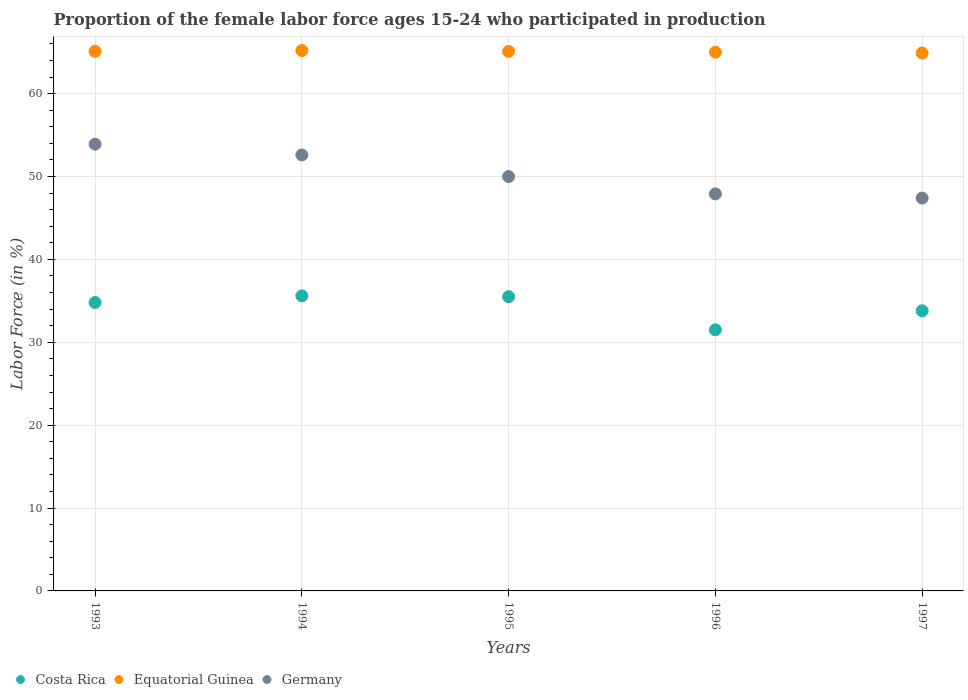How many different coloured dotlines are there?
Provide a succinct answer. 3. Is the number of dotlines equal to the number of legend labels?
Provide a succinct answer. Yes. What is the proportion of the female labor force who participated in production in Costa Rica in 1997?
Your answer should be compact. 33.8. Across all years, what is the maximum proportion of the female labor force who participated in production in Costa Rica?
Your answer should be very brief. 35.6. Across all years, what is the minimum proportion of the female labor force who participated in production in Equatorial Guinea?
Your answer should be very brief. 64.9. In which year was the proportion of the female labor force who participated in production in Equatorial Guinea maximum?
Ensure brevity in your answer.  1994. In which year was the proportion of the female labor force who participated in production in Germany minimum?
Make the answer very short. 1997. What is the total proportion of the female labor force who participated in production in Costa Rica in the graph?
Ensure brevity in your answer.  171.2. What is the difference between the proportion of the female labor force who participated in production in Equatorial Guinea in 1995 and that in 1996?
Your response must be concise. 0.1. What is the difference between the proportion of the female labor force who participated in production in Germany in 1995 and the proportion of the female labor force who participated in production in Equatorial Guinea in 1996?
Make the answer very short. -15. What is the average proportion of the female labor force who participated in production in Germany per year?
Ensure brevity in your answer.  50.36. In the year 1996, what is the difference between the proportion of the female labor force who participated in production in Equatorial Guinea and proportion of the female labor force who participated in production in Germany?
Make the answer very short. 17.1. What is the ratio of the proportion of the female labor force who participated in production in Equatorial Guinea in 1994 to that in 1997?
Ensure brevity in your answer.  1. Is the difference between the proportion of the female labor force who participated in production in Equatorial Guinea in 1993 and 1997 greater than the difference between the proportion of the female labor force who participated in production in Germany in 1993 and 1997?
Provide a short and direct response. No. What is the difference between the highest and the second highest proportion of the female labor force who participated in production in Equatorial Guinea?
Your answer should be very brief. 0.1. What is the difference between the highest and the lowest proportion of the female labor force who participated in production in Equatorial Guinea?
Provide a short and direct response. 0.3. In how many years, is the proportion of the female labor force who participated in production in Costa Rica greater than the average proportion of the female labor force who participated in production in Costa Rica taken over all years?
Your answer should be compact. 3. Does the proportion of the female labor force who participated in production in Equatorial Guinea monotonically increase over the years?
Keep it short and to the point. No. Are the values on the major ticks of Y-axis written in scientific E-notation?
Give a very brief answer. No. Does the graph contain any zero values?
Provide a short and direct response. No. How many legend labels are there?
Offer a very short reply. 3. What is the title of the graph?
Offer a very short reply. Proportion of the female labor force ages 15-24 who participated in production. Does "Morocco" appear as one of the legend labels in the graph?
Ensure brevity in your answer.  No. What is the label or title of the X-axis?
Offer a very short reply. Years. What is the label or title of the Y-axis?
Keep it short and to the point. Labor Force (in %). What is the Labor Force (in %) in Costa Rica in 1993?
Provide a succinct answer. 34.8. What is the Labor Force (in %) of Equatorial Guinea in 1993?
Ensure brevity in your answer.  65.1. What is the Labor Force (in %) in Germany in 1993?
Keep it short and to the point. 53.9. What is the Labor Force (in %) of Costa Rica in 1994?
Give a very brief answer. 35.6. What is the Labor Force (in %) in Equatorial Guinea in 1994?
Ensure brevity in your answer.  65.2. What is the Labor Force (in %) of Germany in 1994?
Make the answer very short. 52.6. What is the Labor Force (in %) in Costa Rica in 1995?
Your answer should be very brief. 35.5. What is the Labor Force (in %) in Equatorial Guinea in 1995?
Your answer should be compact. 65.1. What is the Labor Force (in %) of Germany in 1995?
Make the answer very short. 50. What is the Labor Force (in %) in Costa Rica in 1996?
Your answer should be very brief. 31.5. What is the Labor Force (in %) in Germany in 1996?
Give a very brief answer. 47.9. What is the Labor Force (in %) of Costa Rica in 1997?
Offer a terse response. 33.8. What is the Labor Force (in %) in Equatorial Guinea in 1997?
Keep it short and to the point. 64.9. What is the Labor Force (in %) of Germany in 1997?
Ensure brevity in your answer.  47.4. Across all years, what is the maximum Labor Force (in %) of Costa Rica?
Your answer should be very brief. 35.6. Across all years, what is the maximum Labor Force (in %) in Equatorial Guinea?
Offer a very short reply. 65.2. Across all years, what is the maximum Labor Force (in %) of Germany?
Offer a terse response. 53.9. Across all years, what is the minimum Labor Force (in %) of Costa Rica?
Make the answer very short. 31.5. Across all years, what is the minimum Labor Force (in %) of Equatorial Guinea?
Offer a terse response. 64.9. Across all years, what is the minimum Labor Force (in %) in Germany?
Offer a terse response. 47.4. What is the total Labor Force (in %) of Costa Rica in the graph?
Ensure brevity in your answer.  171.2. What is the total Labor Force (in %) in Equatorial Guinea in the graph?
Offer a terse response. 325.3. What is the total Labor Force (in %) in Germany in the graph?
Offer a terse response. 251.8. What is the difference between the Labor Force (in %) in Costa Rica in 1993 and that in 1994?
Your response must be concise. -0.8. What is the difference between the Labor Force (in %) of Equatorial Guinea in 1993 and that in 1994?
Offer a terse response. -0.1. What is the difference between the Labor Force (in %) of Germany in 1993 and that in 1994?
Keep it short and to the point. 1.3. What is the difference between the Labor Force (in %) in Costa Rica in 1993 and that in 1995?
Give a very brief answer. -0.7. What is the difference between the Labor Force (in %) of Equatorial Guinea in 1993 and that in 1995?
Your answer should be compact. 0. What is the difference between the Labor Force (in %) of Germany in 1993 and that in 1995?
Ensure brevity in your answer.  3.9. What is the difference between the Labor Force (in %) of Germany in 1993 and that in 1996?
Provide a short and direct response. 6. What is the difference between the Labor Force (in %) in Germany in 1994 and that in 1995?
Offer a very short reply. 2.6. What is the difference between the Labor Force (in %) of Costa Rica in 1994 and that in 1996?
Ensure brevity in your answer.  4.1. What is the difference between the Labor Force (in %) in Germany in 1994 and that in 1996?
Offer a terse response. 4.7. What is the difference between the Labor Force (in %) in Costa Rica in 1994 and that in 1997?
Offer a very short reply. 1.8. What is the difference between the Labor Force (in %) in Germany in 1994 and that in 1997?
Provide a succinct answer. 5.2. What is the difference between the Labor Force (in %) in Costa Rica in 1995 and that in 1996?
Make the answer very short. 4. What is the difference between the Labor Force (in %) of Equatorial Guinea in 1996 and that in 1997?
Ensure brevity in your answer.  0.1. What is the difference between the Labor Force (in %) in Costa Rica in 1993 and the Labor Force (in %) in Equatorial Guinea in 1994?
Give a very brief answer. -30.4. What is the difference between the Labor Force (in %) in Costa Rica in 1993 and the Labor Force (in %) in Germany in 1994?
Offer a terse response. -17.8. What is the difference between the Labor Force (in %) in Costa Rica in 1993 and the Labor Force (in %) in Equatorial Guinea in 1995?
Provide a succinct answer. -30.3. What is the difference between the Labor Force (in %) of Costa Rica in 1993 and the Labor Force (in %) of Germany in 1995?
Your answer should be compact. -15.2. What is the difference between the Labor Force (in %) in Equatorial Guinea in 1993 and the Labor Force (in %) in Germany in 1995?
Offer a terse response. 15.1. What is the difference between the Labor Force (in %) of Costa Rica in 1993 and the Labor Force (in %) of Equatorial Guinea in 1996?
Offer a terse response. -30.2. What is the difference between the Labor Force (in %) of Costa Rica in 1993 and the Labor Force (in %) of Germany in 1996?
Provide a short and direct response. -13.1. What is the difference between the Labor Force (in %) in Equatorial Guinea in 1993 and the Labor Force (in %) in Germany in 1996?
Your response must be concise. 17.2. What is the difference between the Labor Force (in %) in Costa Rica in 1993 and the Labor Force (in %) in Equatorial Guinea in 1997?
Offer a terse response. -30.1. What is the difference between the Labor Force (in %) in Equatorial Guinea in 1993 and the Labor Force (in %) in Germany in 1997?
Make the answer very short. 17.7. What is the difference between the Labor Force (in %) in Costa Rica in 1994 and the Labor Force (in %) in Equatorial Guinea in 1995?
Make the answer very short. -29.5. What is the difference between the Labor Force (in %) of Costa Rica in 1994 and the Labor Force (in %) of Germany in 1995?
Provide a short and direct response. -14.4. What is the difference between the Labor Force (in %) of Equatorial Guinea in 1994 and the Labor Force (in %) of Germany in 1995?
Make the answer very short. 15.2. What is the difference between the Labor Force (in %) in Costa Rica in 1994 and the Labor Force (in %) in Equatorial Guinea in 1996?
Your answer should be very brief. -29.4. What is the difference between the Labor Force (in %) in Equatorial Guinea in 1994 and the Labor Force (in %) in Germany in 1996?
Give a very brief answer. 17.3. What is the difference between the Labor Force (in %) of Costa Rica in 1994 and the Labor Force (in %) of Equatorial Guinea in 1997?
Provide a succinct answer. -29.3. What is the difference between the Labor Force (in %) of Equatorial Guinea in 1994 and the Labor Force (in %) of Germany in 1997?
Offer a terse response. 17.8. What is the difference between the Labor Force (in %) in Costa Rica in 1995 and the Labor Force (in %) in Equatorial Guinea in 1996?
Your answer should be compact. -29.5. What is the difference between the Labor Force (in %) of Costa Rica in 1995 and the Labor Force (in %) of Germany in 1996?
Your answer should be very brief. -12.4. What is the difference between the Labor Force (in %) of Equatorial Guinea in 1995 and the Labor Force (in %) of Germany in 1996?
Your answer should be compact. 17.2. What is the difference between the Labor Force (in %) of Costa Rica in 1995 and the Labor Force (in %) of Equatorial Guinea in 1997?
Ensure brevity in your answer.  -29.4. What is the difference between the Labor Force (in %) of Costa Rica in 1995 and the Labor Force (in %) of Germany in 1997?
Provide a short and direct response. -11.9. What is the difference between the Labor Force (in %) in Equatorial Guinea in 1995 and the Labor Force (in %) in Germany in 1997?
Your response must be concise. 17.7. What is the difference between the Labor Force (in %) of Costa Rica in 1996 and the Labor Force (in %) of Equatorial Guinea in 1997?
Keep it short and to the point. -33.4. What is the difference between the Labor Force (in %) of Costa Rica in 1996 and the Labor Force (in %) of Germany in 1997?
Offer a terse response. -15.9. What is the difference between the Labor Force (in %) in Equatorial Guinea in 1996 and the Labor Force (in %) in Germany in 1997?
Provide a succinct answer. 17.6. What is the average Labor Force (in %) of Costa Rica per year?
Ensure brevity in your answer.  34.24. What is the average Labor Force (in %) of Equatorial Guinea per year?
Keep it short and to the point. 65.06. What is the average Labor Force (in %) of Germany per year?
Ensure brevity in your answer.  50.36. In the year 1993, what is the difference between the Labor Force (in %) of Costa Rica and Labor Force (in %) of Equatorial Guinea?
Your answer should be very brief. -30.3. In the year 1993, what is the difference between the Labor Force (in %) in Costa Rica and Labor Force (in %) in Germany?
Keep it short and to the point. -19.1. In the year 1993, what is the difference between the Labor Force (in %) in Equatorial Guinea and Labor Force (in %) in Germany?
Provide a succinct answer. 11.2. In the year 1994, what is the difference between the Labor Force (in %) in Costa Rica and Labor Force (in %) in Equatorial Guinea?
Your answer should be very brief. -29.6. In the year 1994, what is the difference between the Labor Force (in %) of Costa Rica and Labor Force (in %) of Germany?
Provide a short and direct response. -17. In the year 1995, what is the difference between the Labor Force (in %) of Costa Rica and Labor Force (in %) of Equatorial Guinea?
Ensure brevity in your answer.  -29.6. In the year 1996, what is the difference between the Labor Force (in %) in Costa Rica and Labor Force (in %) in Equatorial Guinea?
Keep it short and to the point. -33.5. In the year 1996, what is the difference between the Labor Force (in %) in Costa Rica and Labor Force (in %) in Germany?
Offer a very short reply. -16.4. In the year 1997, what is the difference between the Labor Force (in %) in Costa Rica and Labor Force (in %) in Equatorial Guinea?
Make the answer very short. -31.1. What is the ratio of the Labor Force (in %) in Costa Rica in 1993 to that in 1994?
Your answer should be compact. 0.98. What is the ratio of the Labor Force (in %) of Equatorial Guinea in 1993 to that in 1994?
Your answer should be compact. 1. What is the ratio of the Labor Force (in %) of Germany in 1993 to that in 1994?
Offer a very short reply. 1.02. What is the ratio of the Labor Force (in %) of Costa Rica in 1993 to that in 1995?
Your answer should be compact. 0.98. What is the ratio of the Labor Force (in %) in Equatorial Guinea in 1993 to that in 1995?
Keep it short and to the point. 1. What is the ratio of the Labor Force (in %) in Germany in 1993 to that in 1995?
Keep it short and to the point. 1.08. What is the ratio of the Labor Force (in %) of Costa Rica in 1993 to that in 1996?
Offer a terse response. 1.1. What is the ratio of the Labor Force (in %) of Equatorial Guinea in 1993 to that in 1996?
Provide a short and direct response. 1. What is the ratio of the Labor Force (in %) in Germany in 1993 to that in 1996?
Ensure brevity in your answer.  1.13. What is the ratio of the Labor Force (in %) of Costa Rica in 1993 to that in 1997?
Give a very brief answer. 1.03. What is the ratio of the Labor Force (in %) in Germany in 1993 to that in 1997?
Your answer should be very brief. 1.14. What is the ratio of the Labor Force (in %) of Germany in 1994 to that in 1995?
Give a very brief answer. 1.05. What is the ratio of the Labor Force (in %) in Costa Rica in 1994 to that in 1996?
Ensure brevity in your answer.  1.13. What is the ratio of the Labor Force (in %) of Germany in 1994 to that in 1996?
Offer a terse response. 1.1. What is the ratio of the Labor Force (in %) of Costa Rica in 1994 to that in 1997?
Make the answer very short. 1.05. What is the ratio of the Labor Force (in %) in Germany in 1994 to that in 1997?
Offer a very short reply. 1.11. What is the ratio of the Labor Force (in %) in Costa Rica in 1995 to that in 1996?
Offer a terse response. 1.13. What is the ratio of the Labor Force (in %) of Germany in 1995 to that in 1996?
Your answer should be compact. 1.04. What is the ratio of the Labor Force (in %) of Costa Rica in 1995 to that in 1997?
Your answer should be very brief. 1.05. What is the ratio of the Labor Force (in %) of Equatorial Guinea in 1995 to that in 1997?
Keep it short and to the point. 1. What is the ratio of the Labor Force (in %) of Germany in 1995 to that in 1997?
Offer a very short reply. 1.05. What is the ratio of the Labor Force (in %) in Costa Rica in 1996 to that in 1997?
Provide a short and direct response. 0.93. What is the ratio of the Labor Force (in %) in Germany in 1996 to that in 1997?
Provide a succinct answer. 1.01. What is the difference between the highest and the second highest Labor Force (in %) of Costa Rica?
Your answer should be compact. 0.1. What is the difference between the highest and the second highest Labor Force (in %) in Equatorial Guinea?
Your answer should be very brief. 0.1. 